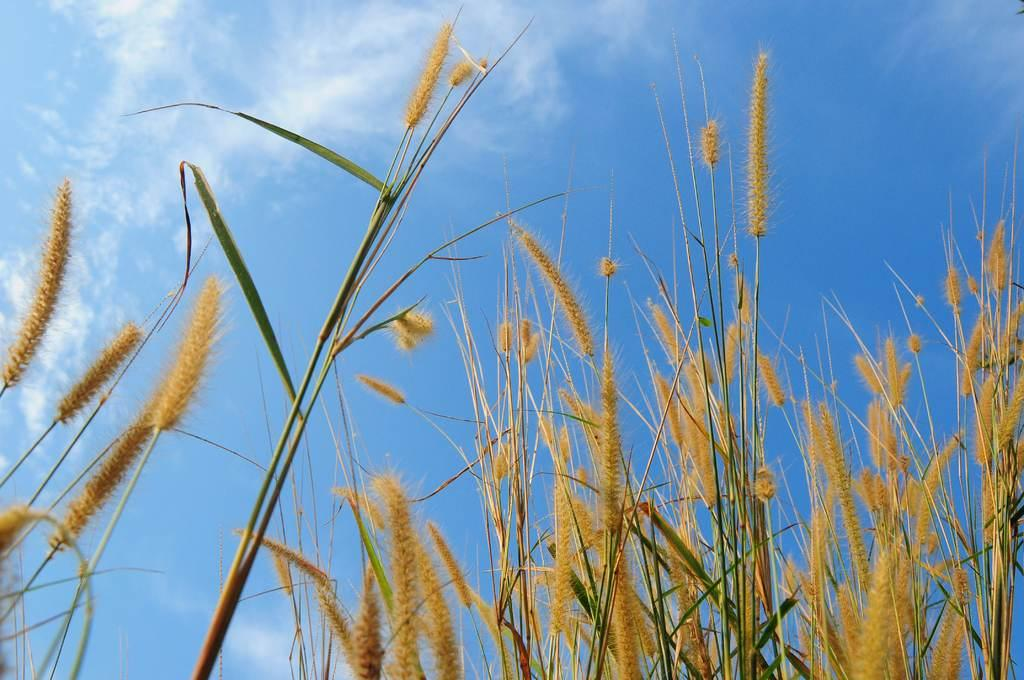What type of plants are in the image? There are brown color wheat plants in the image. What can be seen in the background of the image? There is a blue sky visible in the background of the image. What type of leather is being used to make the drum in the image? There is no drum or leather present in the image; it features brown color wheat plants and a blue sky. 